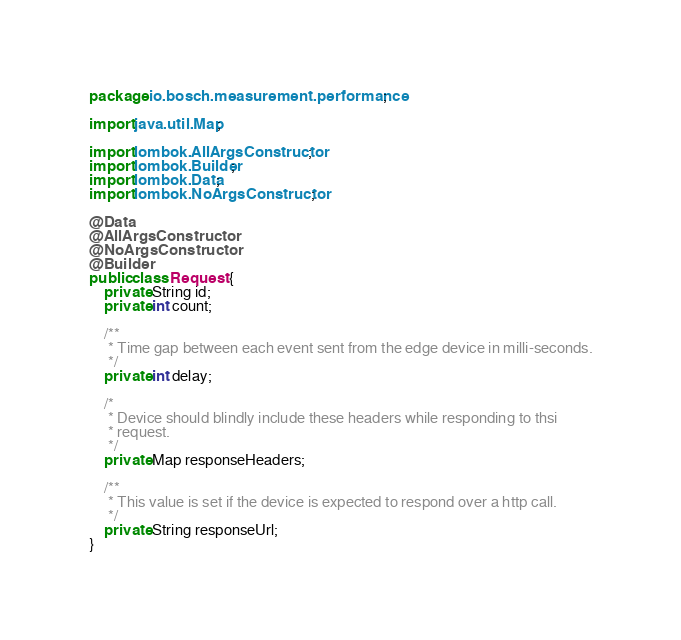<code> <loc_0><loc_0><loc_500><loc_500><_Java_>package io.bosch.measurement.performance;

import java.util.Map;

import lombok.AllArgsConstructor;
import lombok.Builder;
import lombok.Data;
import lombok.NoArgsConstructor;

@Data
@AllArgsConstructor
@NoArgsConstructor
@Builder
public class Request {
    private String id;
    private int count;

    /**
     * Time gap between each event sent from the edge device in milli-seconds.
     */
    private int delay;

    /*
     * Device should blindly include these headers while responding to thsi
     * request.
     */
    private Map responseHeaders;

    /**
     * This value is set if the device is expected to respond over a http call.
     */
    private String responseUrl;
}
</code> 